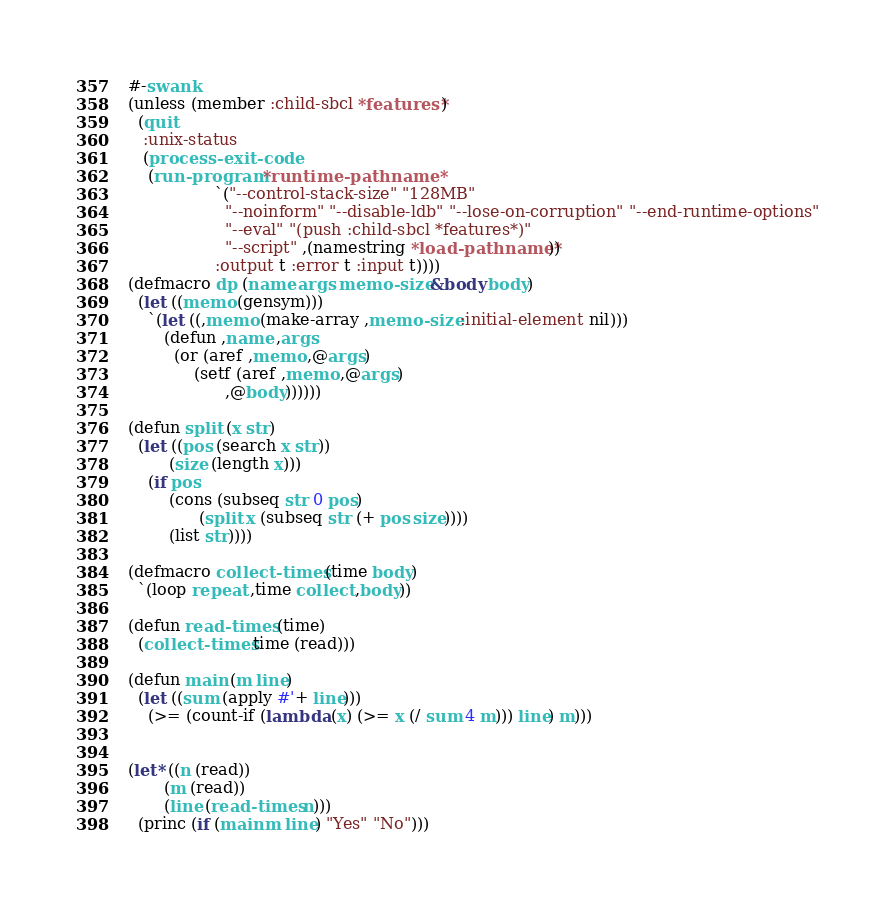Convert code to text. <code><loc_0><loc_0><loc_500><loc_500><_Lisp_>#-swank
(unless (member :child-sbcl *features*)
  (quit
   :unix-status
   (process-exit-code
    (run-program *runtime-pathname*
                 `("--control-stack-size" "128MB"
                   "--noinform" "--disable-ldb" "--lose-on-corruption" "--end-runtime-options"
                   "--eval" "(push :child-sbcl *features*)"
                   "--script" ,(namestring *load-pathname*))
                 :output t :error t :input t))))
(defmacro dp (name args memo-size &body body)
  (let ((memo (gensym)))
    `(let ((,memo (make-array ,memo-size :initial-element nil)))
       (defun ,name ,args
         (or (aref ,memo ,@args)
             (setf (aref ,memo ,@args)
                   ,@body))))))

(defun split (x str)
  (let ((pos (search x str))
        (size (length x)))
    (if pos
        (cons (subseq str 0 pos)
              (split x (subseq str (+ pos size))))
        (list str))))

(defmacro collect-times (time body)
  `(loop repeat ,time collect ,body))

(defun read-times (time)
  (collect-times time (read)))

(defun main (m line)
  (let ((sum (apply #'+ line)))
    (>= (count-if (lambda (x) (>= x (/ sum 4 m))) line) m)))


(let* ((n (read))
       (m (read))
       (line (read-times n)))
  (princ (if (main m line) "Yes" "No")))
</code> 